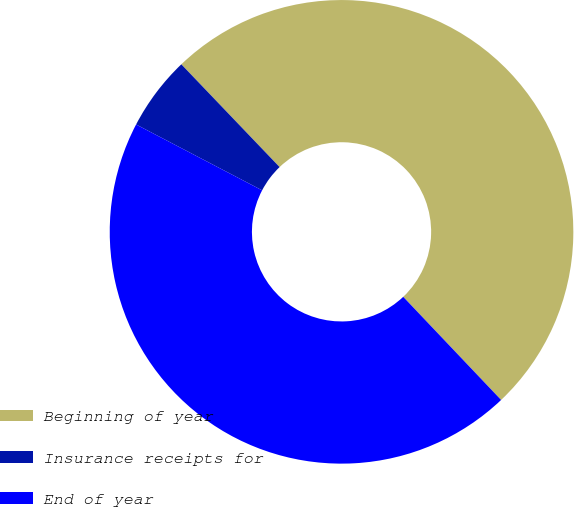Convert chart. <chart><loc_0><loc_0><loc_500><loc_500><pie_chart><fcel>Beginning of year<fcel>Insurance receipts for<fcel>End of year<nl><fcel>50.06%<fcel>5.19%<fcel>44.75%<nl></chart> 